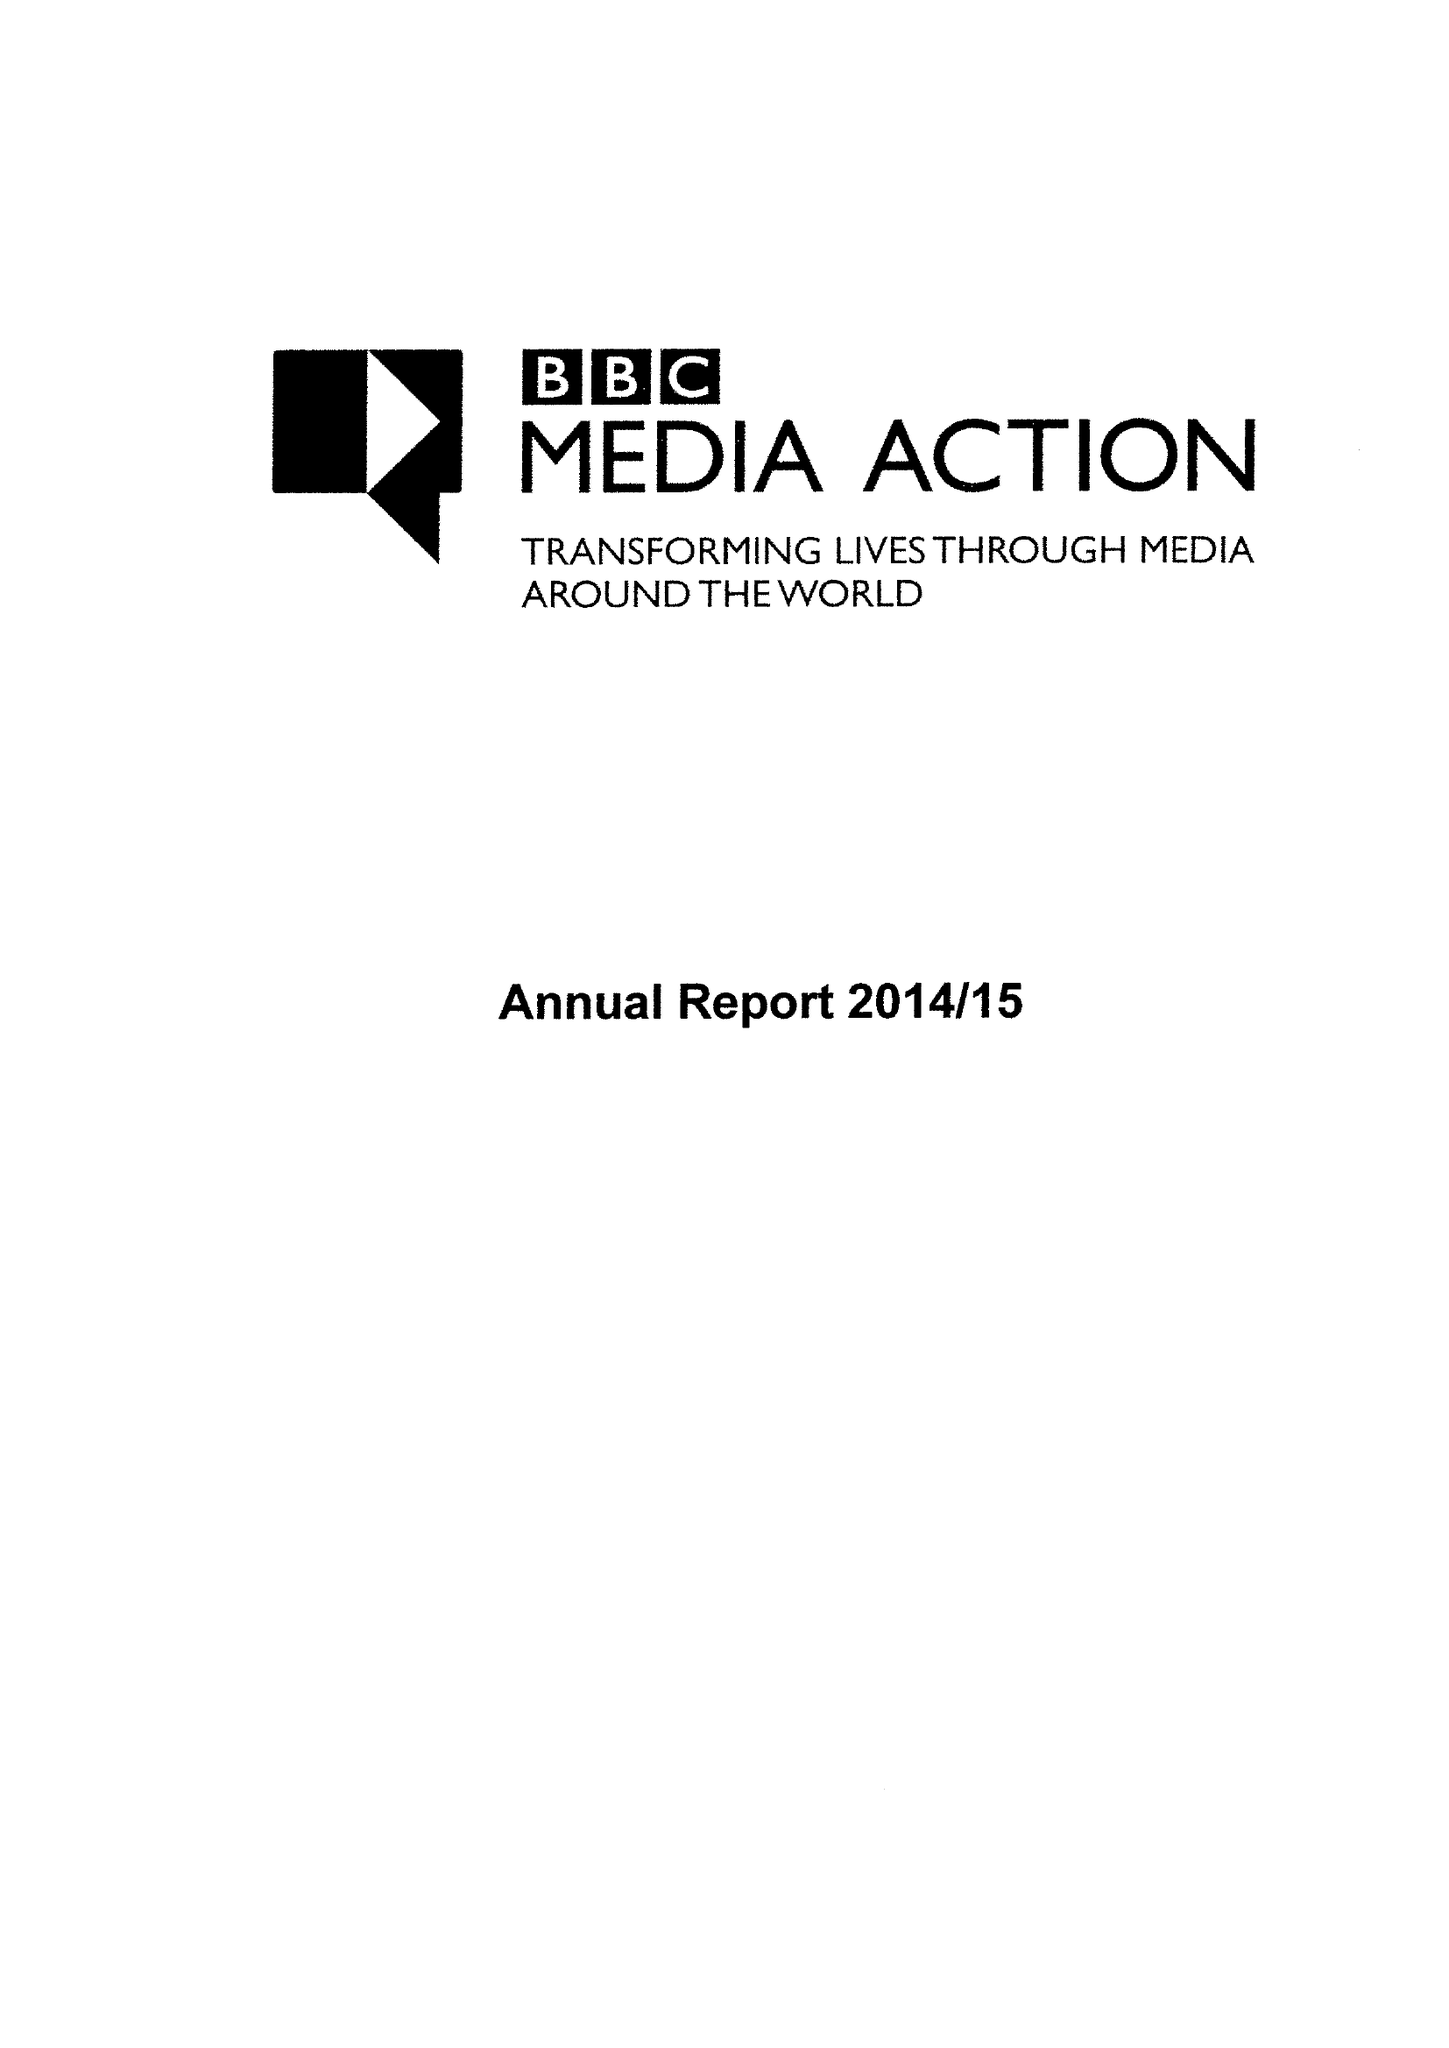What is the value for the address__post_town?
Answer the question using a single word or phrase. LONDON 